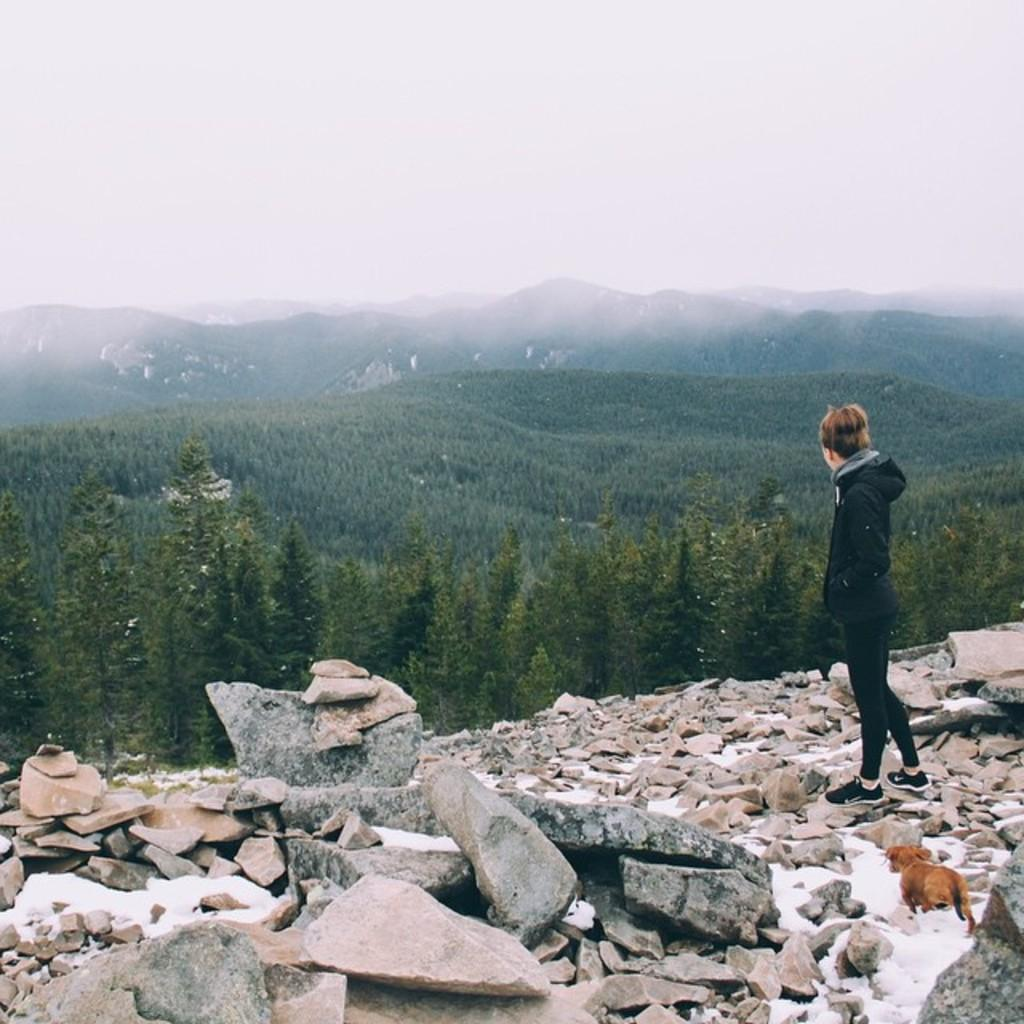Who is the main subject in the image? There is a boy in the image. What is the boy doing in the image? The boy is standing on rocks. What can be seen in the background of the image? There are trees and mountains in the background of the image. What type of lamp is hanging from the tree in the image? There is no lamp present in the image; it features a boy standing on rocks with trees and mountains in the background. 